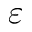Convert formula to latex. <formula><loc_0><loc_0><loc_500><loc_500>\varepsilon</formula> 